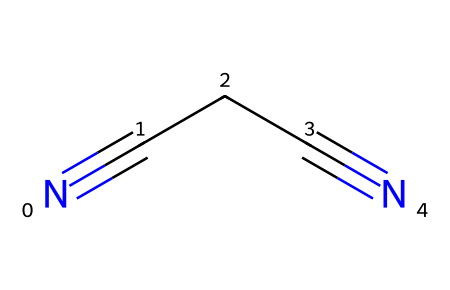What is the name of this chemical? The chemical represented by the SMILES is known as succinonitrile. The structure indicates two cyano groups (-C≡N) attached to a carbon chain, characteristic of succinonitrile.
Answer: succinonitrile How many carbon atoms are in this molecule? The SMILES notation shows a chain of four carbon atoms connecting two nitrile groups, indicating there are four carbon atoms total in succinonitrile.
Answer: 4 How many nitrogen atoms are present in this structure? Each nitrile group in the structure contains one nitrogen atom; since there are two nitrile groups, there are two nitrogen atoms in total.
Answer: 2 What type of bonds are present between the carbon and nitrogen atoms? The chemical contains triple bonds between carbon and nitrogen in the nitrile groups, specifically C≡N, which indicates a strong covalent bond characteristic of nitriles.
Answer: triple bonds Why is succinonitrile used in battery technology? Succinonitrile has a high dielectric constant and ion conductivity, which enables it to act as a suitable solvent and electrolyte in battery technology, enhancing performance.
Answer: high dielectric constant What functional group is represented in this molecule? The molecule contains the nitrile functional group, which is characterized by the presence of a carbon atom triple-bonded to a nitrogen atom (C≡N).
Answer: nitrile Can this molecule form hydrogen bonds? Due to the absence of hydrogen atoms directly bonded to the nitrogen atoms, succinonitrile cannot form hydrogen bonds, limiting its interaction with polar solvents.
Answer: no 